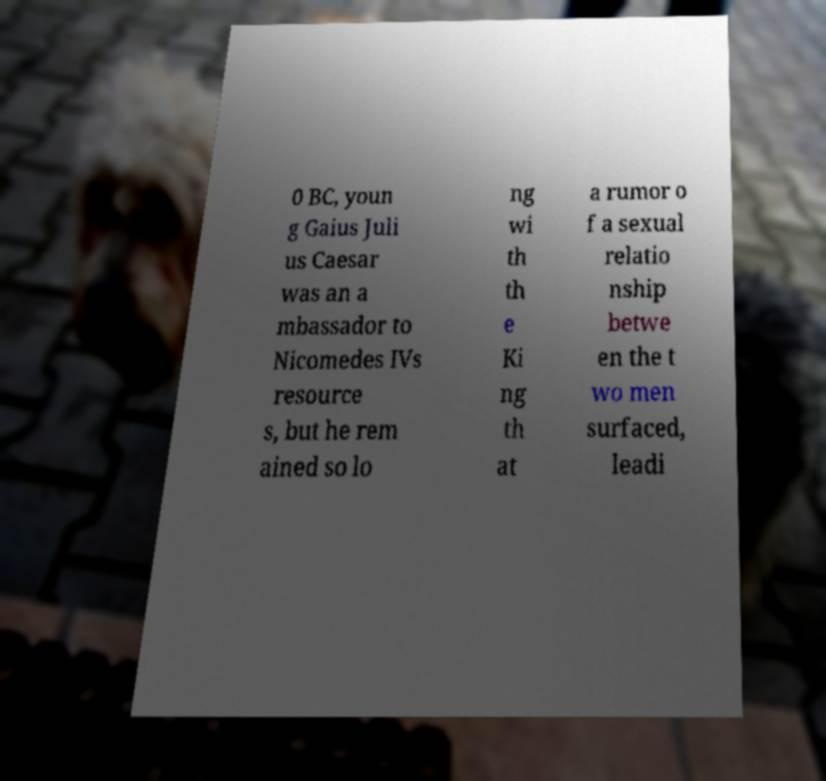Please identify and transcribe the text found in this image. 0 BC, youn g Gaius Juli us Caesar was an a mbassador to Nicomedes IVs resource s, but he rem ained so lo ng wi th th e Ki ng th at a rumor o f a sexual relatio nship betwe en the t wo men surfaced, leadi 